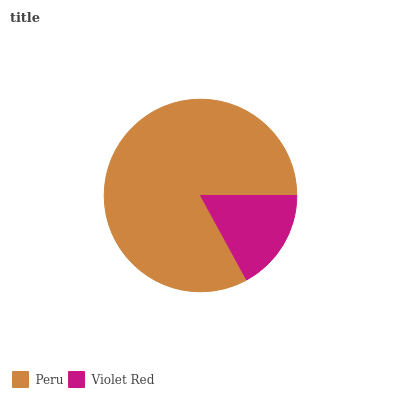Is Violet Red the minimum?
Answer yes or no. Yes. Is Peru the maximum?
Answer yes or no. Yes. Is Violet Red the maximum?
Answer yes or no. No. Is Peru greater than Violet Red?
Answer yes or no. Yes. Is Violet Red less than Peru?
Answer yes or no. Yes. Is Violet Red greater than Peru?
Answer yes or no. No. Is Peru less than Violet Red?
Answer yes or no. No. Is Peru the high median?
Answer yes or no. Yes. Is Violet Red the low median?
Answer yes or no. Yes. Is Violet Red the high median?
Answer yes or no. No. Is Peru the low median?
Answer yes or no. No. 